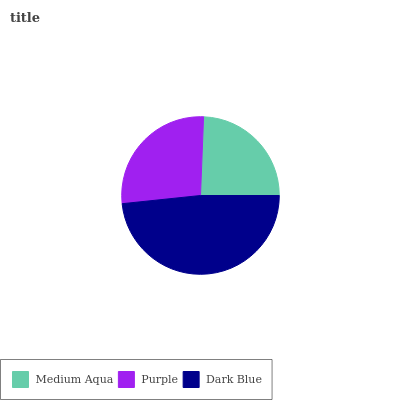Is Medium Aqua the minimum?
Answer yes or no. Yes. Is Dark Blue the maximum?
Answer yes or no. Yes. Is Purple the minimum?
Answer yes or no. No. Is Purple the maximum?
Answer yes or no. No. Is Purple greater than Medium Aqua?
Answer yes or no. Yes. Is Medium Aqua less than Purple?
Answer yes or no. Yes. Is Medium Aqua greater than Purple?
Answer yes or no. No. Is Purple less than Medium Aqua?
Answer yes or no. No. Is Purple the high median?
Answer yes or no. Yes. Is Purple the low median?
Answer yes or no. Yes. Is Dark Blue the high median?
Answer yes or no. No. Is Medium Aqua the low median?
Answer yes or no. No. 